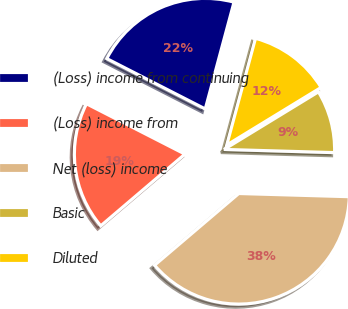Convert chart. <chart><loc_0><loc_0><loc_500><loc_500><pie_chart><fcel>(Loss) income from continuing<fcel>(Loss) income from<fcel>Net (loss) income<fcel>Basic<fcel>Diluted<nl><fcel>21.66%<fcel>18.75%<fcel>38.31%<fcel>9.18%<fcel>12.09%<nl></chart> 